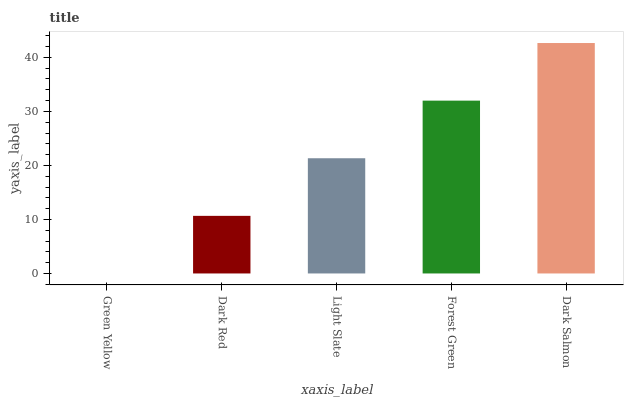Is Green Yellow the minimum?
Answer yes or no. Yes. Is Dark Salmon the maximum?
Answer yes or no. Yes. Is Dark Red the minimum?
Answer yes or no. No. Is Dark Red the maximum?
Answer yes or no. No. Is Dark Red greater than Green Yellow?
Answer yes or no. Yes. Is Green Yellow less than Dark Red?
Answer yes or no. Yes. Is Green Yellow greater than Dark Red?
Answer yes or no. No. Is Dark Red less than Green Yellow?
Answer yes or no. No. Is Light Slate the high median?
Answer yes or no. Yes. Is Light Slate the low median?
Answer yes or no. Yes. Is Green Yellow the high median?
Answer yes or no. No. Is Dark Red the low median?
Answer yes or no. No. 